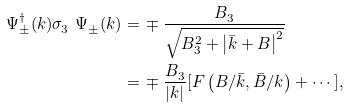<formula> <loc_0><loc_0><loc_500><loc_500>\Psi ^ { \dag } _ { \pm } ( k ) \sigma ^ { \ } _ { 3 } \Psi ^ { \ } _ { \pm } ( k ) = & \, \mp \frac { B ^ { \ } _ { 3 } } { \sqrt { B ^ { 2 } _ { 3 } + \left | \bar { k } + B \right | ^ { 2 } } } \\ = & \, \mp \frac { B ^ { \ } _ { 3 } } { | k | } [ F \left ( B / \bar { k } , \bar { B } / k \right ) + \cdots ] ,</formula> 